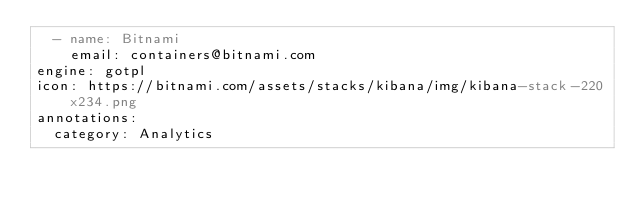<code> <loc_0><loc_0><loc_500><loc_500><_YAML_>  - name: Bitnami
    email: containers@bitnami.com
engine: gotpl
icon: https://bitnami.com/assets/stacks/kibana/img/kibana-stack-220x234.png
annotations:
  category: Analytics
</code> 